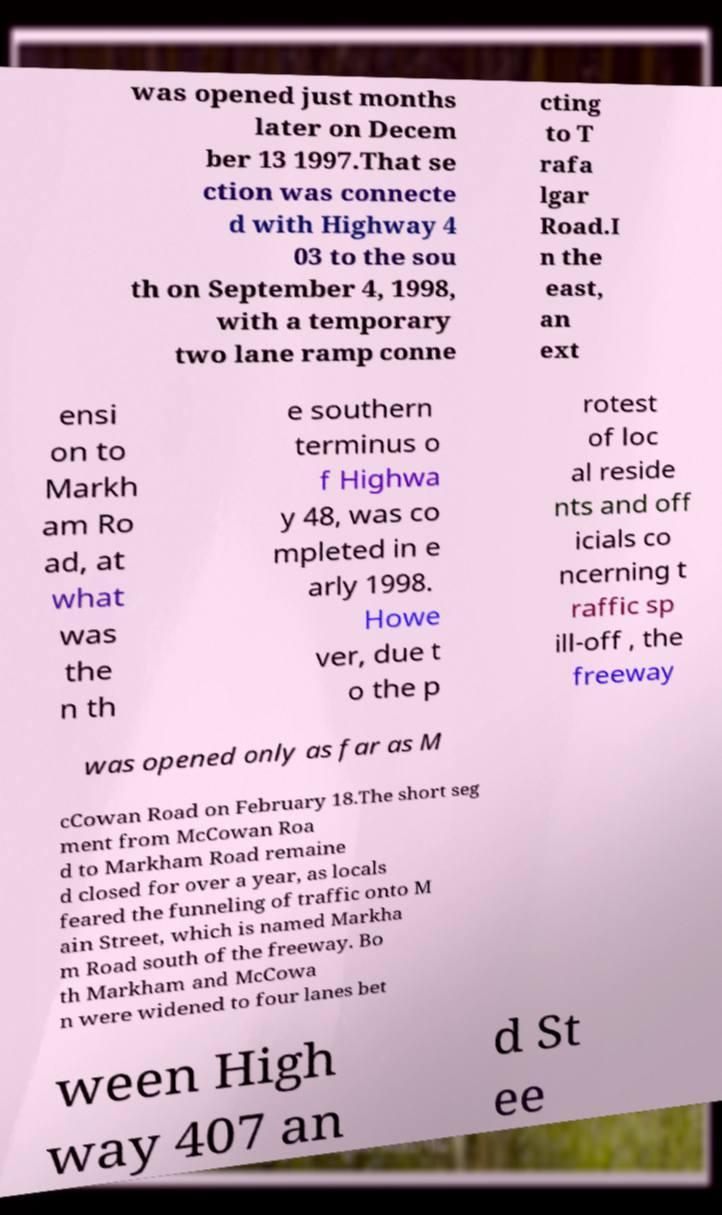There's text embedded in this image that I need extracted. Can you transcribe it verbatim? was opened just months later on Decem ber 13 1997.That se ction was connecte d with Highway 4 03 to the sou th on September 4, 1998, with a temporary two lane ramp conne cting to T rafa lgar Road.I n the east, an ext ensi on to Markh am Ro ad, at what was the n th e southern terminus o f Highwa y 48, was co mpleted in e arly 1998. Howe ver, due t o the p rotest of loc al reside nts and off icials co ncerning t raffic sp ill-off , the freeway was opened only as far as M cCowan Road on February 18.The short seg ment from McCowan Roa d to Markham Road remaine d closed for over a year, as locals feared the funneling of traffic onto M ain Street, which is named Markha m Road south of the freeway. Bo th Markham and McCowa n were widened to four lanes bet ween High way 407 an d St ee 